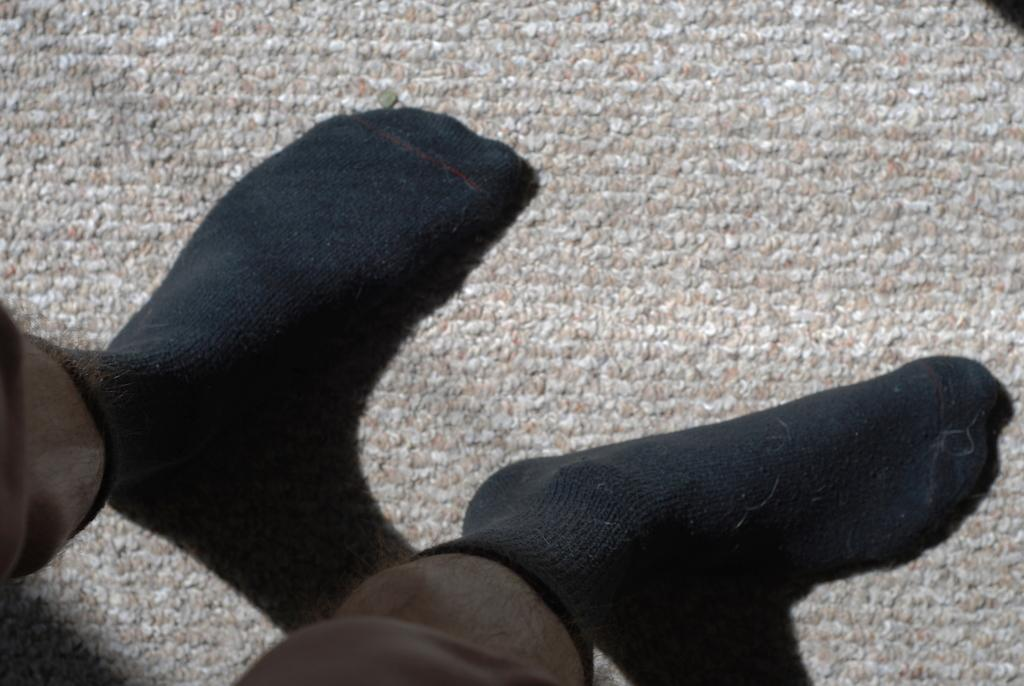What part of a person can be seen in the image? There are legs of a person in the image. What type of clothing is the person wearing on their legs? The person is wearing black socks. What color are the eyes of the person in the image? There are no eyes visible in the image, as only the legs of the person are shown. 